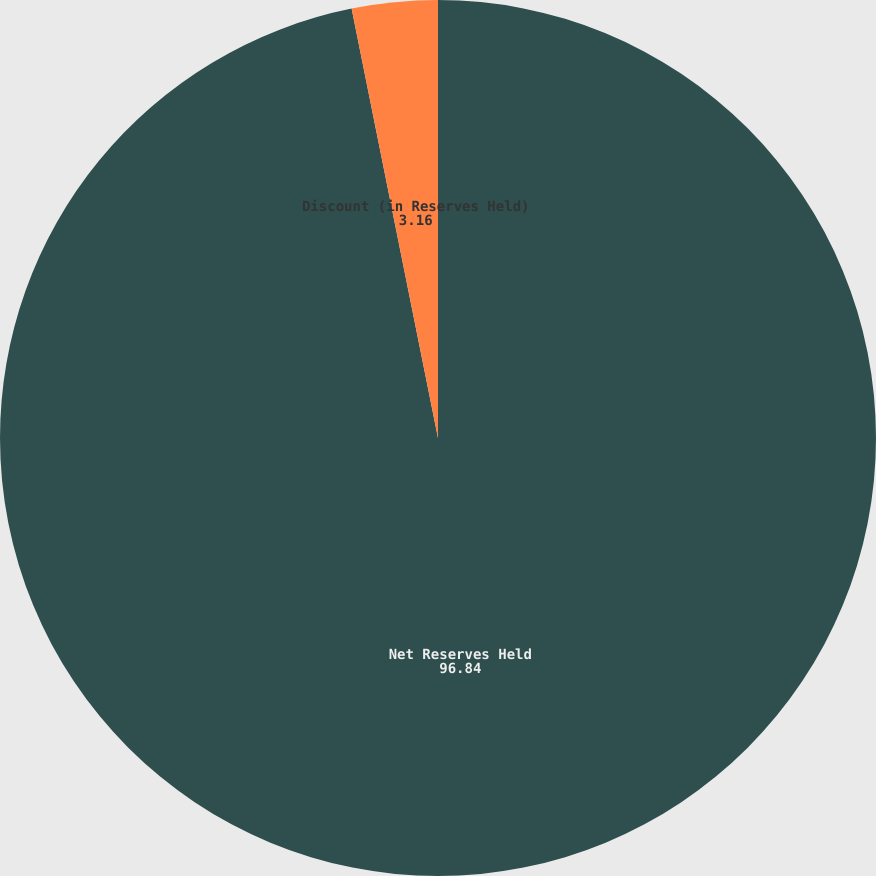Convert chart. <chart><loc_0><loc_0><loc_500><loc_500><pie_chart><fcel>Net Reserves Held<fcel>Discount (in Reserves Held)<nl><fcel>96.84%<fcel>3.16%<nl></chart> 